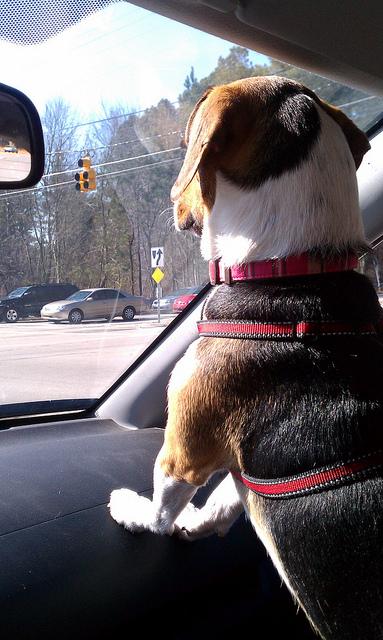Is this a small dog or a large dog?
Short answer required. Small. Is the dog wearing a harness?
Quick response, please. Yes. Should a pet have a seat belt?
Short answer required. Yes. 